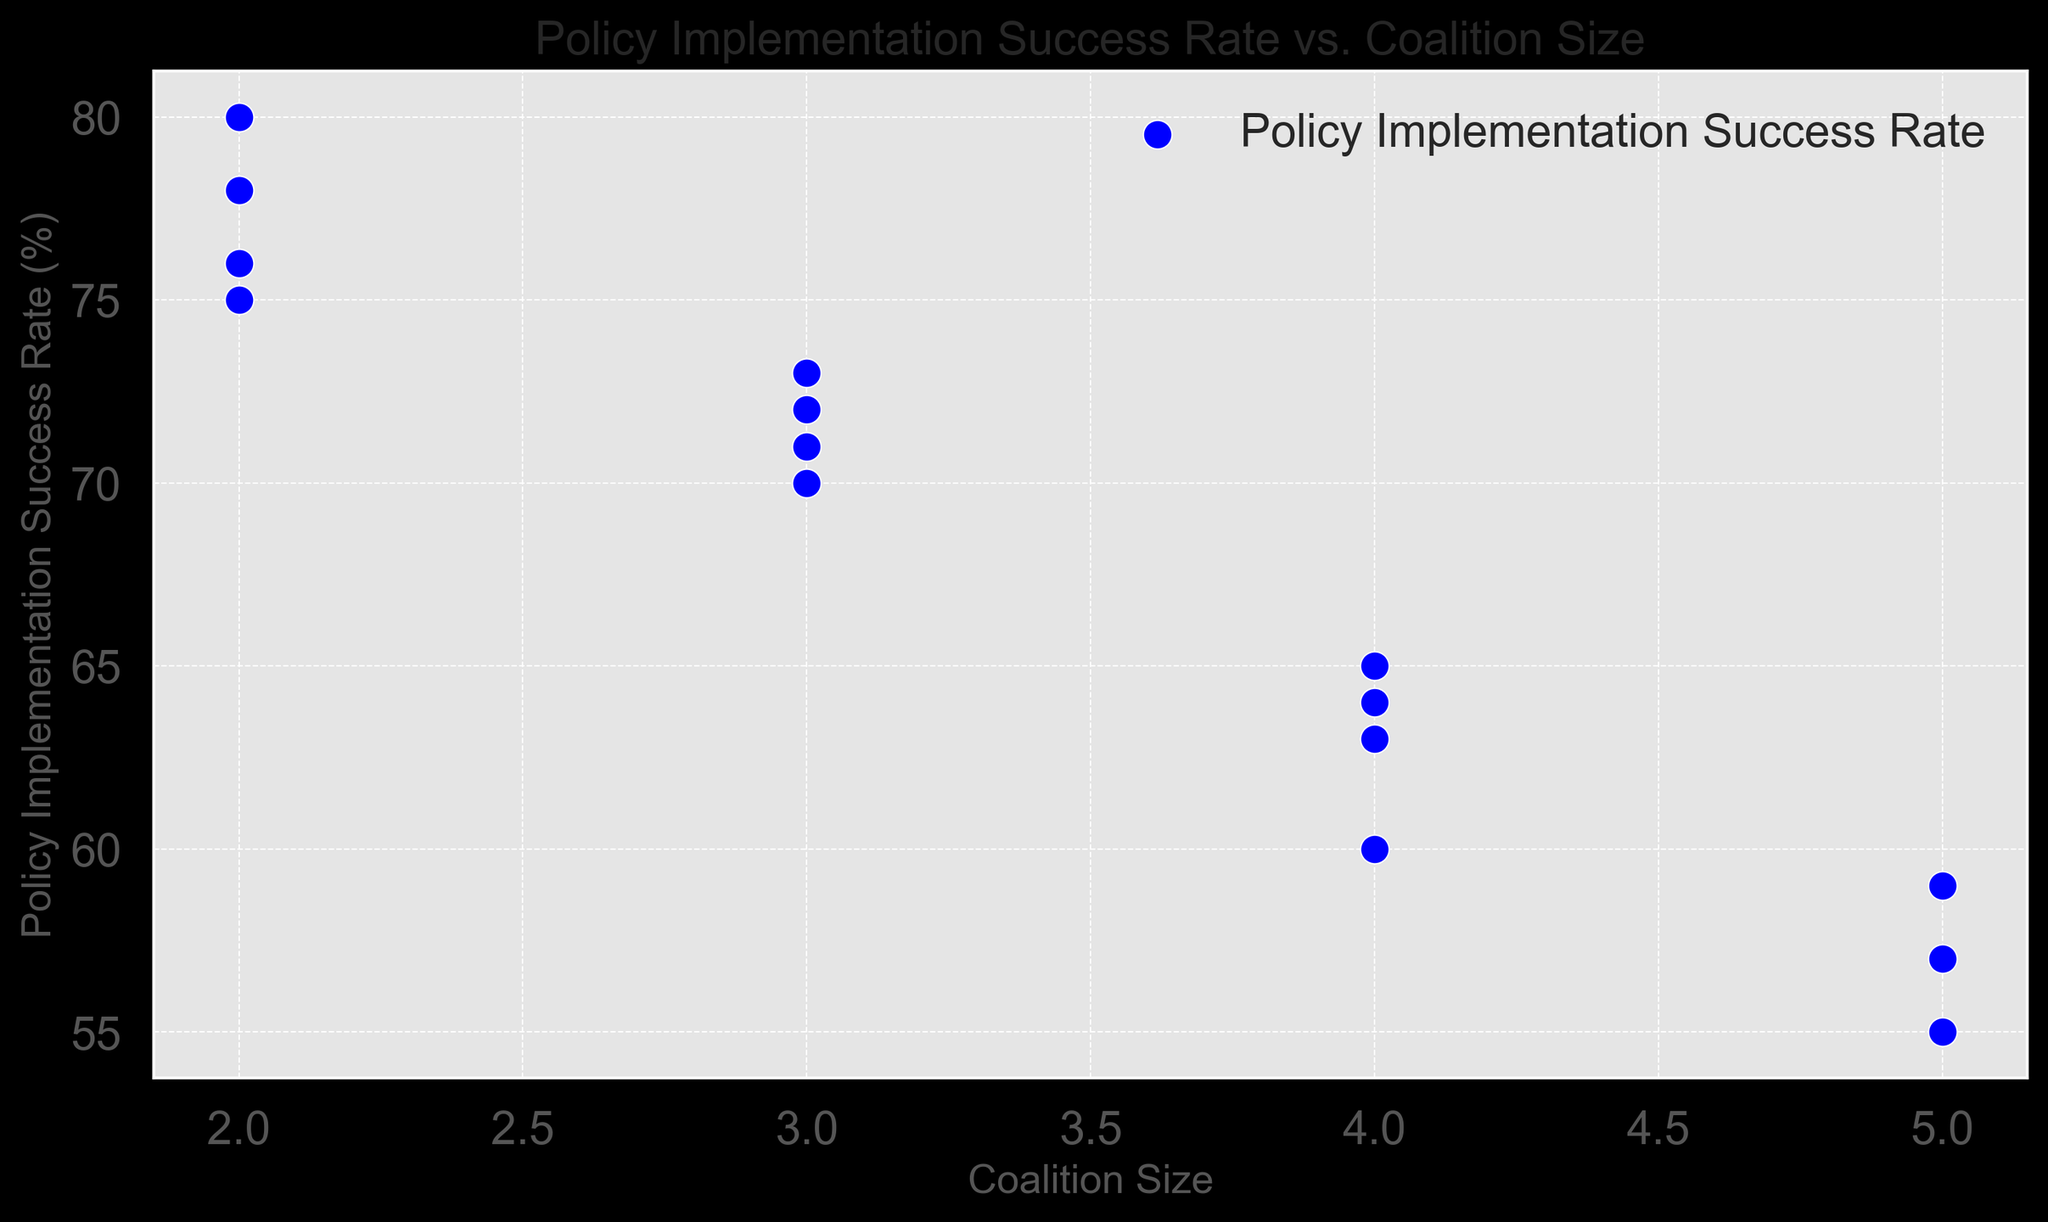What trend does the scatter plot indicate about the relationship between coalition size and policy implementation success rate? The scatter plot shows data points representing the relationship between coalition size and policy implementation success rate. As the coalition size increases from 2 to 5, there is a general downward trend in the success rate, indicating that smaller coalitions tend to have higher policy implementation success rates.
Answer: The success rate decreases as coalition size increases What is the average policy implementation success rate for coalitions of size 4? To find the average success rate for coalitions of size 4, identify all data points with a coalition size of 4: 65, 60, 63, 64. Calculate the mean: (65 + 60 + 63 + 64) / 4 = 252 / 4 = 63.
Answer: 63 Which coalition size has the highest policy implementation success rate and what is that rate? Observing the scatter plot, coalitions of size 2 have the highest policy implementation success rate data point, with the highest rate being 80.
Answer: Coalition size 2 with a rate of 80 How does the average policy implementation success rate for coalitions of size 3 compare to those of size 5? First, calculate the average success rate for size 3: (70 + 73 + 72 + 71) / 4 = 286 / 4 = 71.5. Then, calculate for size 5: (55 + 57 + 59) / 3 = 171 / 3 = 57. Comparing the two averages, the coalition size 3 (71.5) is significantly higher than coalition size 5 (57).
Answer: Coalition size 3 has a higher average (71.5) than size 5 (57) Is there a coalition size that consistently shows a lower policy implementation success rate compared to others? Examining the scatter plot, we can see that the data points for coalition size 5 consistently have lower success rates compared to the points for other coalition sizes (consistently around mid-50s).
Answer: Coalition size 5 What is the median policy implementation success rate for coalitions of size 2? Identify all data points for coalition size 2: 75, 80, 78, 76. Arrange them in ascending order: 75, 76, 78, 80. The median value for an even number of points is the average of the two middle values: (76 + 78) / 2 = 154 / 2 = 77.
Answer: 77 How many coalition size groups have at least one policy implementation success rate above 70%? Observing the scatter plot, coalition size groups of 2, 3, and 4 each have at least one data point above 70%. This makes three groups in total.
Answer: 3 groups Which coalition size has the lowest variability in policy implementation success rates, and how can you tell? We compare the spread of the data points for each coalition size. Coalition size 2 has the most clustered success rates (75-80 range), indicating the lowest variability. The other sizes show more spread out values.
Answer: Coalition size 2 What is the difference between the highest and lowest policy implementation success rates for coalition size 4? Identify the range of values for coalition size 4: 65, 60, 63, 64. The difference between the highest (65) and lowest (60) values is 65 - 60 = 5.
Answer: 5 